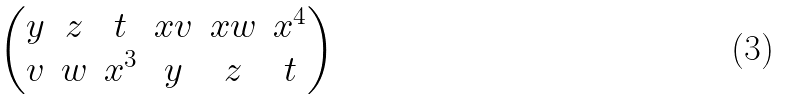Convert formula to latex. <formula><loc_0><loc_0><loc_500><loc_500>\begin{pmatrix} y & z & t & x v & x w & x ^ { 4 } \\ v & w & x ^ { 3 } & y & z & t \end{pmatrix}</formula> 